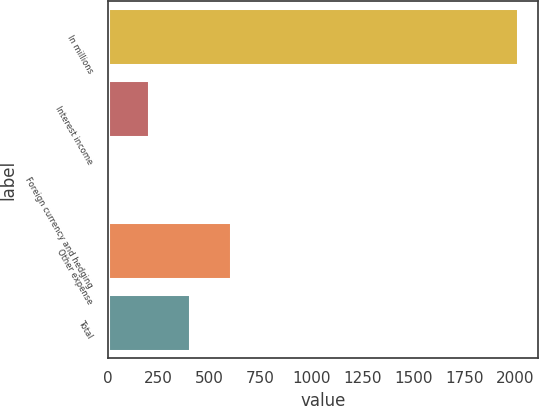Convert chart to OTSL. <chart><loc_0><loc_0><loc_500><loc_500><bar_chart><fcel>In millions<fcel>Interest income<fcel>Foreign currency and hedging<fcel>Other expense<fcel>Total<nl><fcel>2010<fcel>202.8<fcel>2<fcel>604.4<fcel>403.6<nl></chart> 